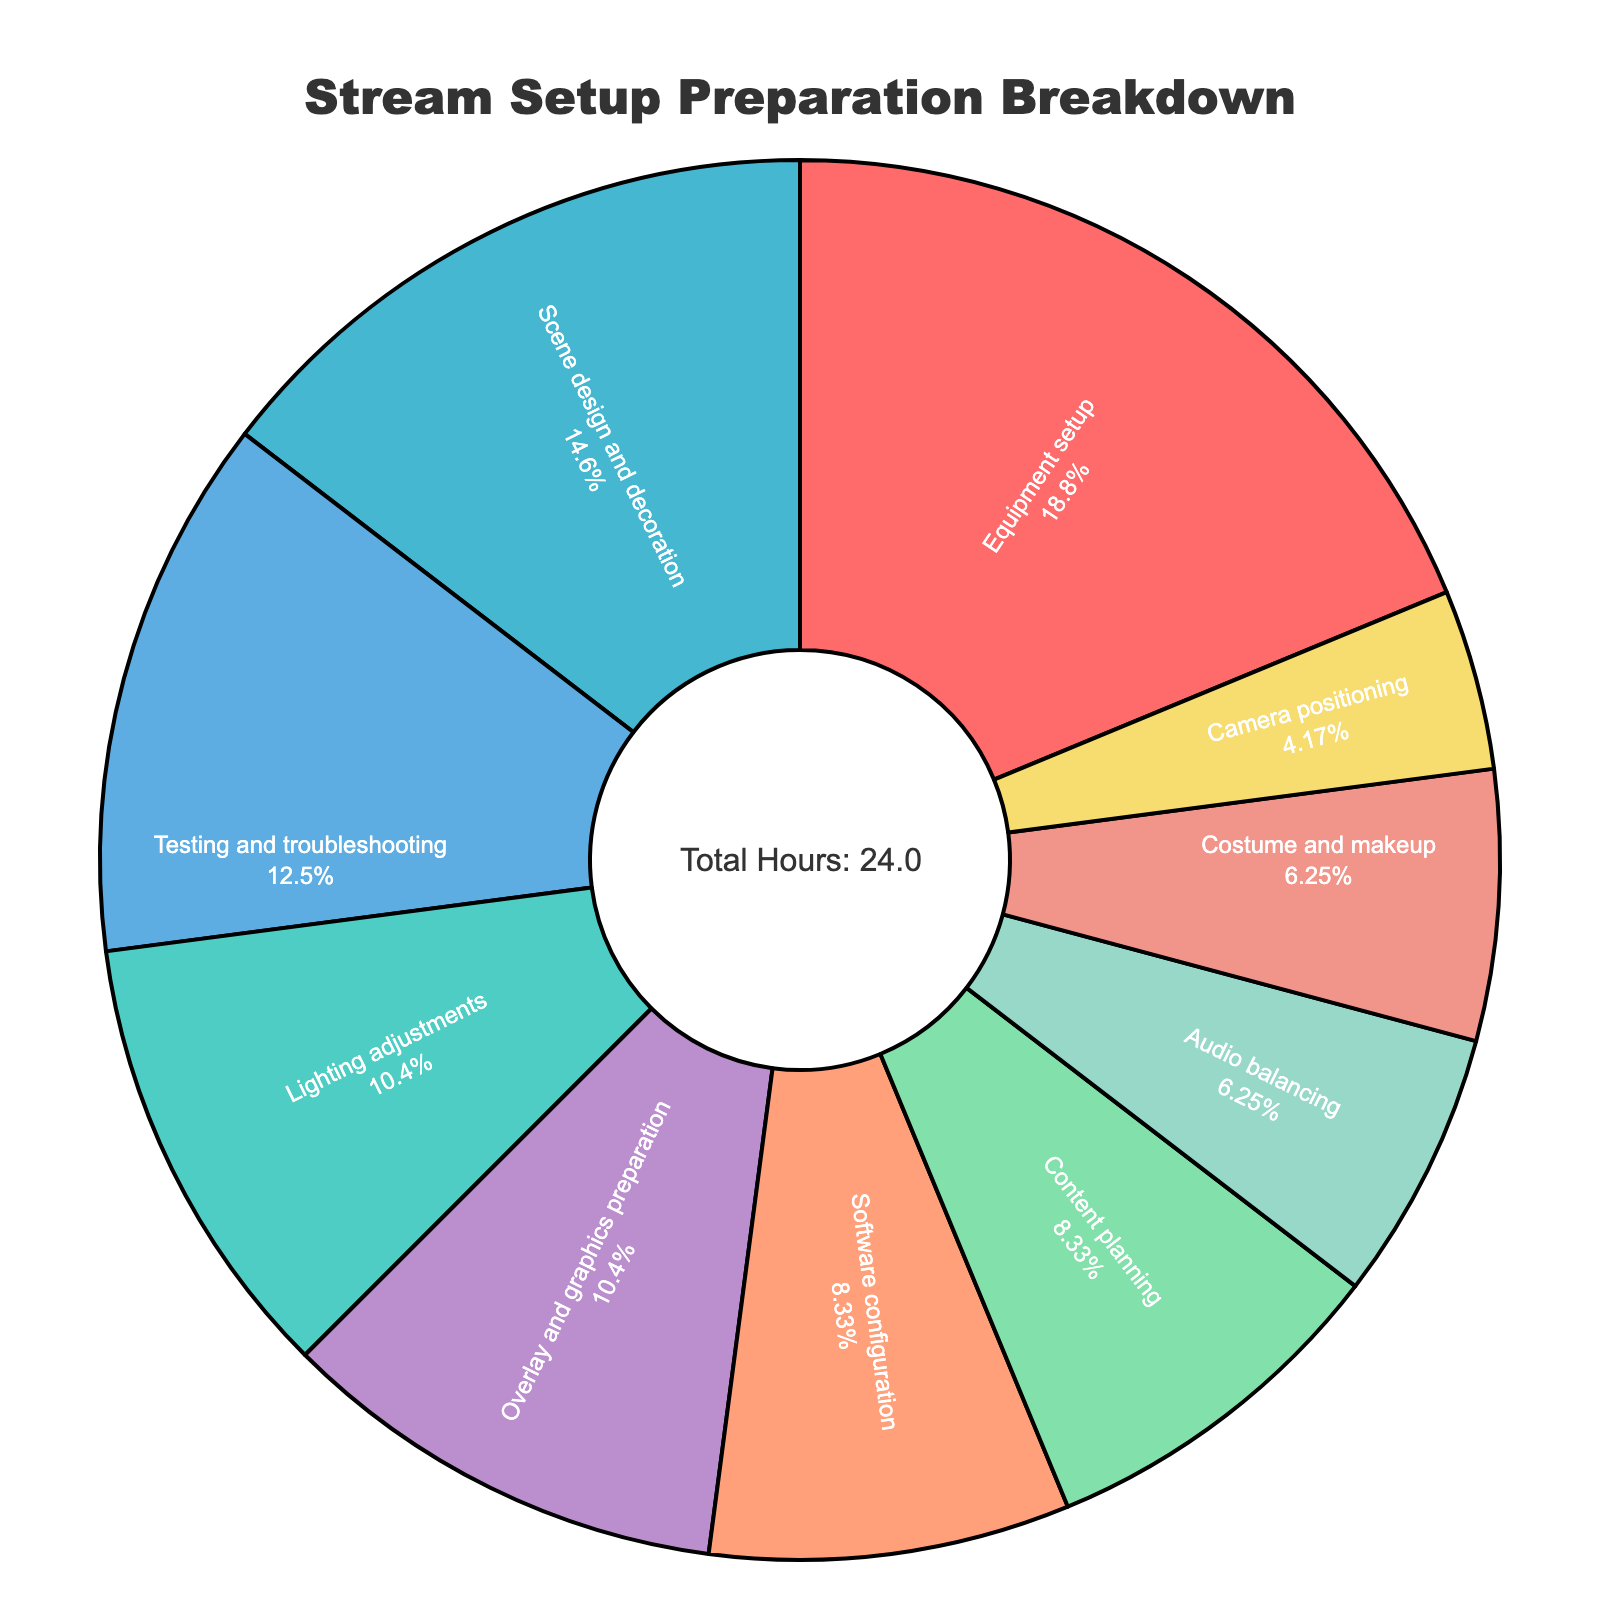Which activity took the most hours? The pie chart shows the activities and their corresponding hours. By looking at the segments, the largest one is "Equipment setup".
Answer: Equipment setup How many total hours are spent on both Lighting adjustments and Scene design and decoration? Add the hours for Lighting adjustments (2.5) and Scene design and decoration (3.5). The total hours are 2.5 + 3.5.
Answer: 6 Which activities took fewer hours than Overlay and graphics preparation? Overlay and graphics preparation took 2.5 hours. The activities that took fewer hours are Camera positioning (1), Audio balancing (1.5), and Costume and makeup (1.5).
Answer: Camera positioning, Audio balancing, Costume and makeup What percentage of time is spent on Testing and troubleshooting? The pie chart should show the percentage for each activity within their segment labels. Locate the segment for Testing and troubleshooting.
Answer: 15.0% What's the combined percentage of Equipment setup and Software configuration? In the pie chart, find the percentages for Equipment setup and Software configuration. Summing them gives the combined percentage.
Answer: 22.5% Which activity has the smallest time allocation? Identify the smallest segment in the pie chart. This corresponds to the activity with the least hours.
Answer: Camera positioning Is more time spent on Content planning or Audio balancing? Compare the segments for Content planning (2 hours) and Audio balancing (1.5 hours). Content planning is larger.
Answer: Content planning How much more time is spent on Scene design and decoration compared to Costume and makeup? Subtract the hours for Costume and makeup (1.5) from Scene design and decoration (3.5). The difference is 3.5 - 1.5.
Answer: 2 What's the total number of hours spent on activities that took exactly 2.5 hours? Find all activities that took 2.5 hours: Lighting adjustments and Overlay and graphics preparation. The total is 2.5 + 2.5.
Answer: 5 What is the percentage of time spent on Costume and makeup out of the total hours? First, find the total hours from the annotation (20). Then calculate the percentage for Costume and makeup (1.5/20 * 100).
Answer: 7.5% 